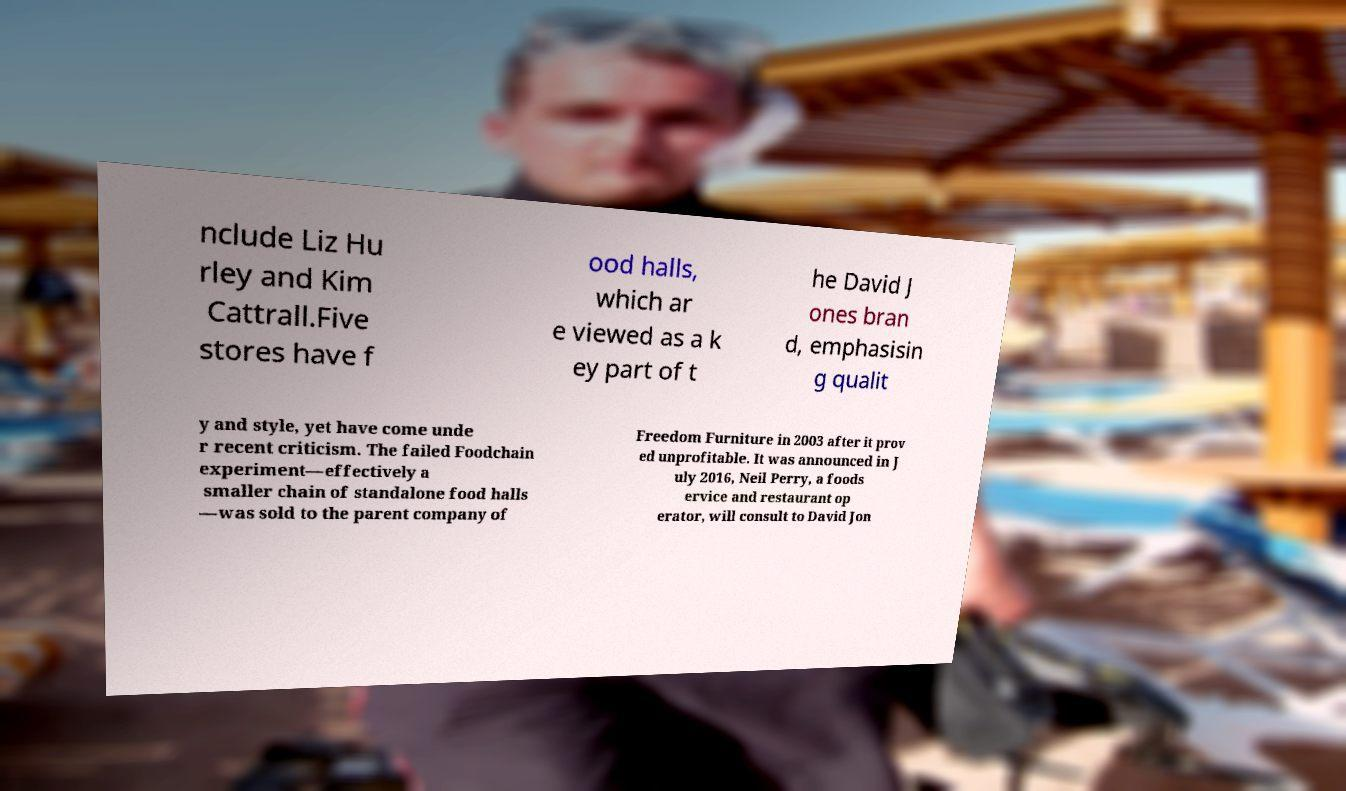Please identify and transcribe the text found in this image. nclude Liz Hu rley and Kim Cattrall.Five stores have f ood halls, which ar e viewed as a k ey part of t he David J ones bran d, emphasisin g qualit y and style, yet have come unde r recent criticism. The failed Foodchain experiment—effectively a smaller chain of standalone food halls —was sold to the parent company of Freedom Furniture in 2003 after it prov ed unprofitable. It was announced in J uly 2016, Neil Perry, a foods ervice and restaurant op erator, will consult to David Jon 